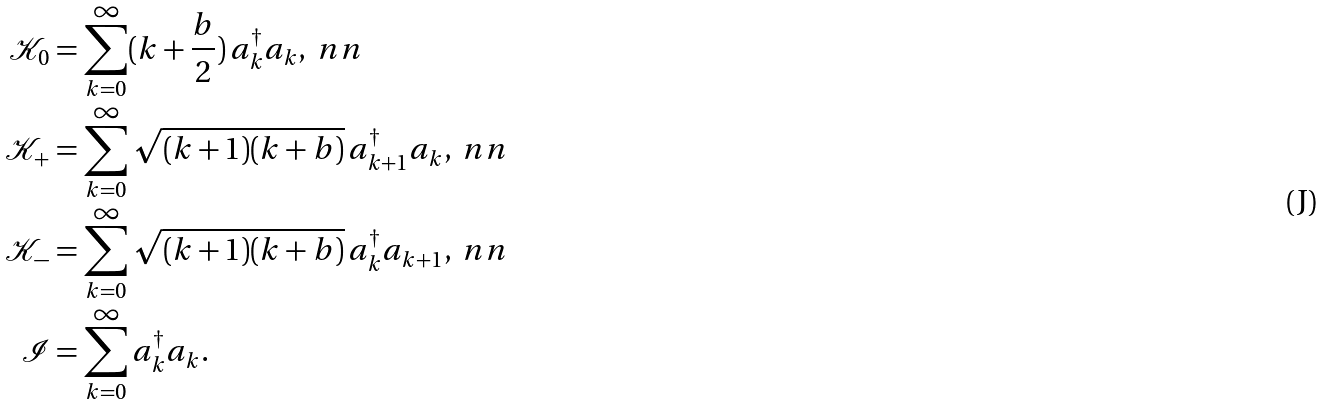<formula> <loc_0><loc_0><loc_500><loc_500>\mathcal { K } _ { 0 } & = \sum _ { k = 0 } ^ { \infty } ( k + \frac { b } { 2 } ) \, a ^ { \dagger } _ { k } a _ { k } , \ n n \\ \mathcal { K } _ { + } & = \sum _ { k = 0 } ^ { \infty } \sqrt { ( k + 1 ) ( k + b ) } \, a _ { k + 1 } ^ { \dagger } a _ { k } , \ n n \\ \mathcal { K } _ { - } & = \sum _ { k = 0 } ^ { \infty } \sqrt { ( k + 1 ) ( k + b ) } \, a _ { k } ^ { \dagger } a _ { k + 1 } , \ n n \\ \mathcal { I } & = \sum _ { k = 0 } ^ { \infty } a ^ { \dagger } _ { k } a _ { k } .</formula> 